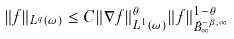<formula> <loc_0><loc_0><loc_500><loc_500>\| f \| _ { L ^ { q } ( \omega ) } \leq C \| \nabla f \| _ { L ^ { 1 } ( \omega ) } ^ { \theta } \| f \| _ { \dot { B } ^ { - \beta , \infty } _ { \infty } } ^ { 1 - \theta }</formula> 